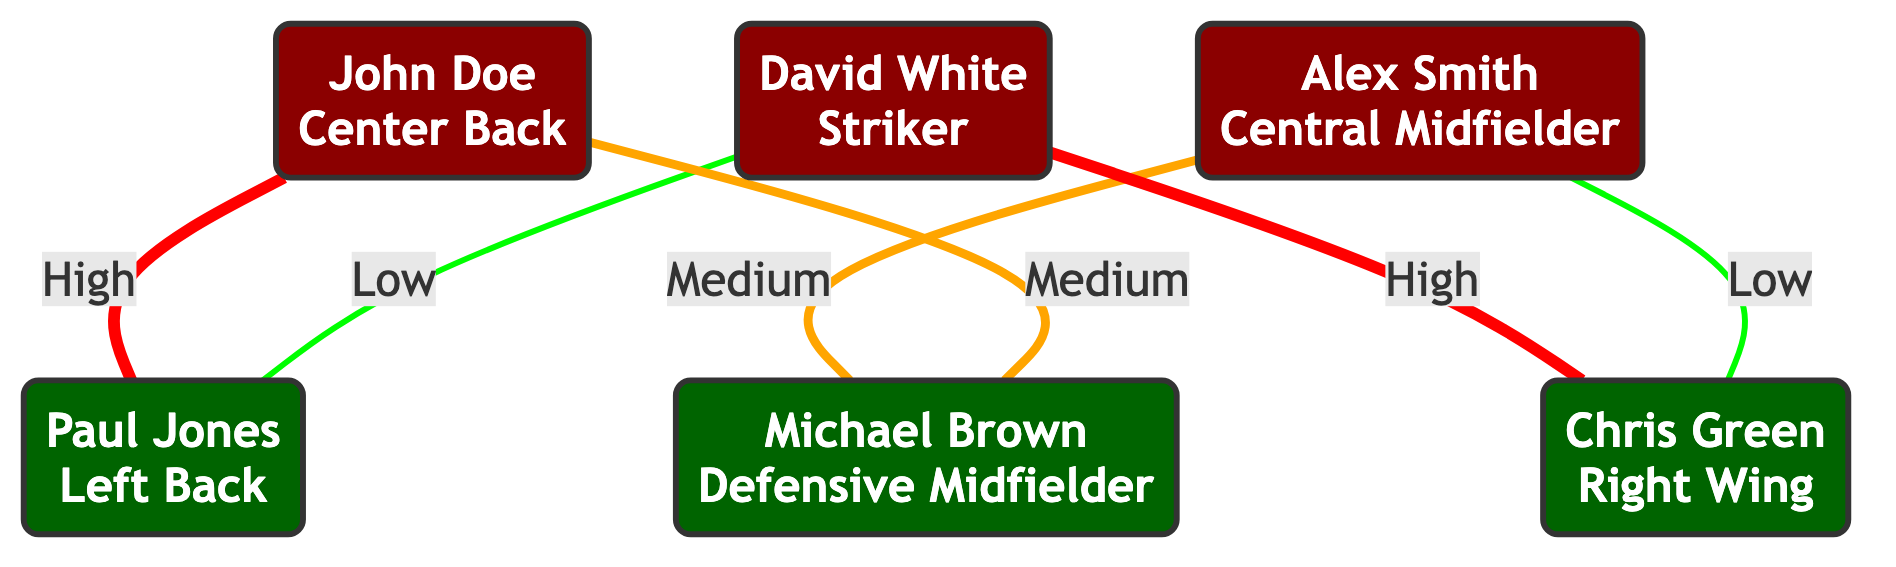What is the mentorship level between John Doe and Paul Jones? The mentorship level between John Doe and Paul Jones is specified directly on the edge connecting them in the graph, which indicates a "High" mentorship level.
Answer: High How many junior players are connected to the senior players? To find the number of junior players connected, examine the edges and count the unique junior players (Paul Jones, Michael Brown, Chris Green) that have connections to senior players. This accounts for a total of three unique junior players.
Answer: 3 Which senior player has the highest number of connections? By analyzing the edges, both John Doe and David White are connected to two players each. However, since we need to determine the total connections overall without considering mentorship levels, we can conclude either of them has the highest number.
Answer: John Doe / David White What is the mentorship level between Alex Smith and Michael Brown? The mentorship connection between Alex Smith and Michael Brown can be found by examining the edge connecting these two players in the graph, which shows a "Medium" mentorship level.
Answer: Medium Who is the junior player connected to David White? To find the junior player connected to David White, we should look at the edges from David White and observe the connections; he is connected to Chris Green and Paul Jones. Both are junior players, but we can select one.
Answer: Chris Green / Paul Jones How many edges are there in total in the graph? The total number of edges can be counted by examining the connections between the senior and junior players in the provided data. There are six edges listed.
Answer: 6 Which junior player has the highest mentorship connection? To determine which junior player has the highest mentorship connection, review the connections to junior players; Paul Jones has low mentorship from David White and high from John Doe. Chris Green has high mentorship from David White. Michael Brown has medium from Alex Smith and medium from John Doe. Therefore, Paul Jones has high, while Chris Green also has high connections. However, since we count high level towards connections only once:
Answer: Paul Jones / Chris Green Is there any junior player with a low mentorship connection? By reviewing the edges, both Paul Jones and Chris Green have low mentorship connections indicated from David White and Alex Smith, respectively. Thus, both qualify as having low mentorship connections.
Answer: Yes Which two senior players are connected to junior players? Looking at the network of edges, the senior players connected to junior players are John Doe and David White, as they both have edges connecting to them.
Answer: John Doe, David White 